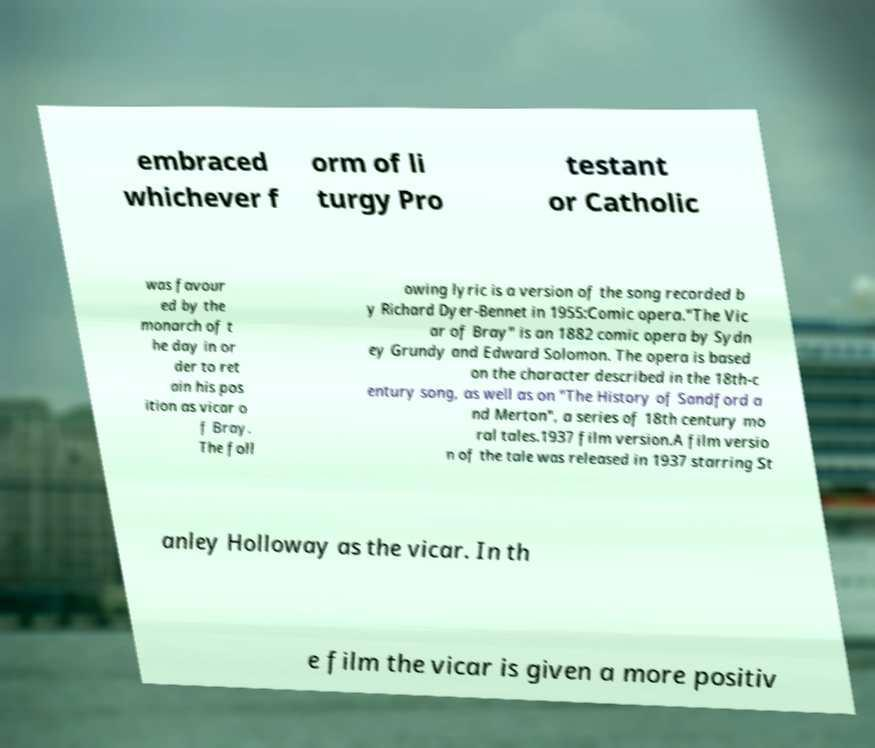I need the written content from this picture converted into text. Can you do that? embraced whichever f orm of li turgy Pro testant or Catholic was favour ed by the monarch of t he day in or der to ret ain his pos ition as vicar o f Bray. The foll owing lyric is a version of the song recorded b y Richard Dyer-Bennet in 1955:Comic opera."The Vic ar of Bray" is an 1882 comic opera by Sydn ey Grundy and Edward Solomon. The opera is based on the character described in the 18th-c entury song, as well as on "The History of Sandford a nd Merton", a series of 18th century mo ral tales.1937 film version.A film versio n of the tale was released in 1937 starring St anley Holloway as the vicar. In th e film the vicar is given a more positiv 